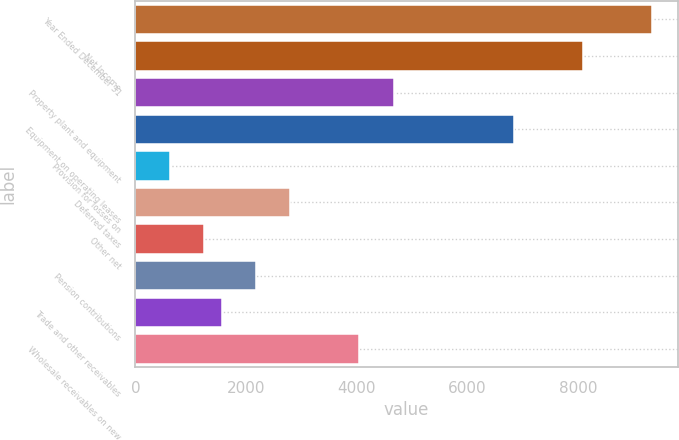<chart> <loc_0><loc_0><loc_500><loc_500><bar_chart><fcel>Year Ended December 31<fcel>Net Income<fcel>Property plant and equipment<fcel>Equipment on operating leases<fcel>Provision for losses on<fcel>Deferred taxes<fcel>Other net<fcel>Pension contributions<fcel>Trade and other receivables<fcel>Wholesale receivables on new<nl><fcel>9340.4<fcel>8095.16<fcel>4670.75<fcel>6849.92<fcel>623.72<fcel>2802.89<fcel>1246.34<fcel>2180.27<fcel>1557.65<fcel>4048.13<nl></chart> 